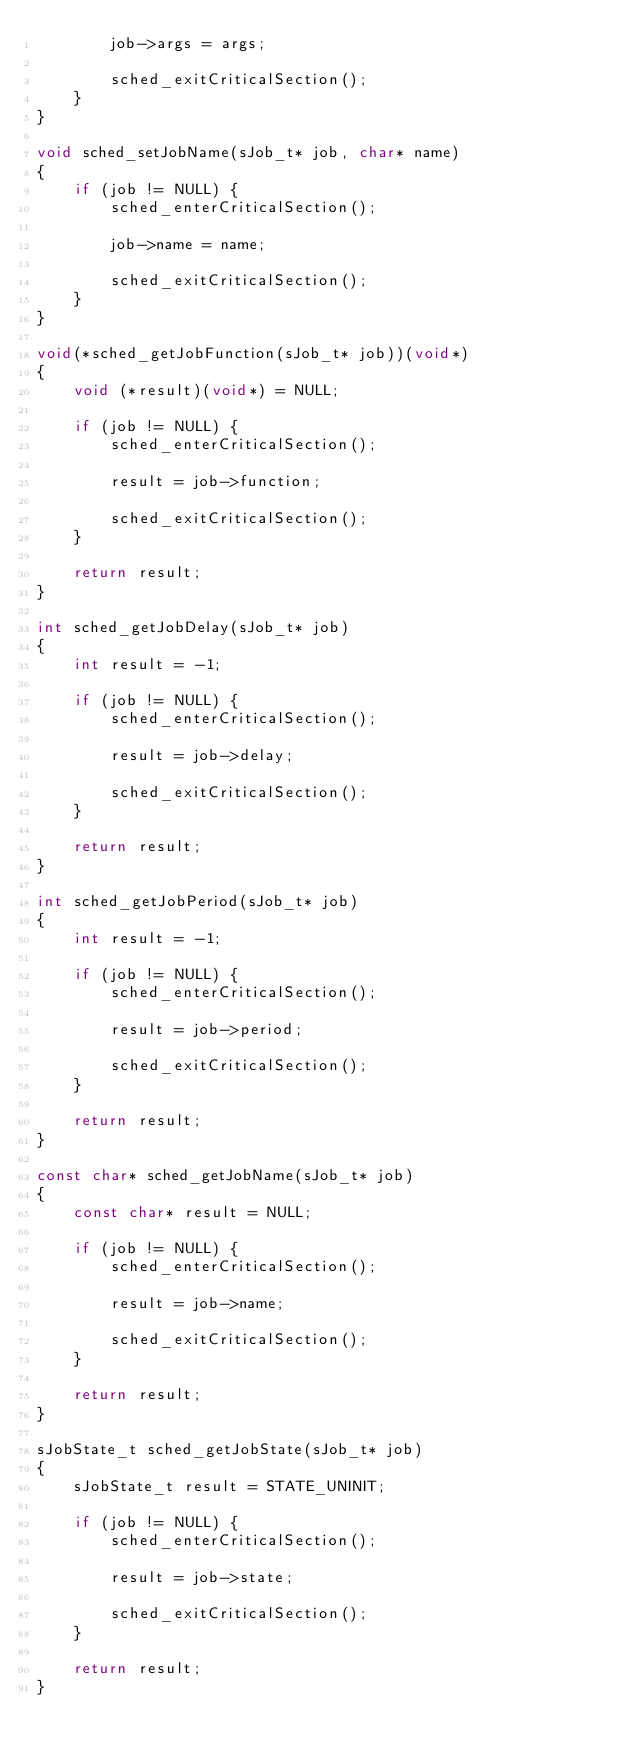Convert code to text. <code><loc_0><loc_0><loc_500><loc_500><_C_>        job->args = args;

        sched_exitCriticalSection();
    }
}

void sched_setJobName(sJob_t* job, char* name)
{
    if (job != NULL) {
        sched_enterCriticalSection();

        job->name = name;

        sched_exitCriticalSection();
    }
}

void(*sched_getJobFunction(sJob_t* job))(void*)
{
    void (*result)(void*) = NULL;

    if (job != NULL) {
        sched_enterCriticalSection();

        result = job->function;

        sched_exitCriticalSection();
    }

    return result;
}

int sched_getJobDelay(sJob_t* job)
{
    int result = -1;

    if (job != NULL) {
        sched_enterCriticalSection();

        result = job->delay;

        sched_exitCriticalSection();
    }

    return result;
}

int sched_getJobPeriod(sJob_t* job)
{
    int result = -1;

    if (job != NULL) {
        sched_enterCriticalSection();

        result = job->period;

        sched_exitCriticalSection();
    }

    return result;
}

const char* sched_getJobName(sJob_t* job)
{
    const char* result = NULL;

    if (job != NULL) {
        sched_enterCriticalSection();

        result = job->name;

        sched_exitCriticalSection();
    }

    return result;
}

sJobState_t sched_getJobState(sJob_t* job)
{
    sJobState_t result = STATE_UNINIT;

    if (job != NULL) {
        sched_enterCriticalSection();

        result = job->state;

        sched_exitCriticalSection();
    }

    return result;
}
</code> 